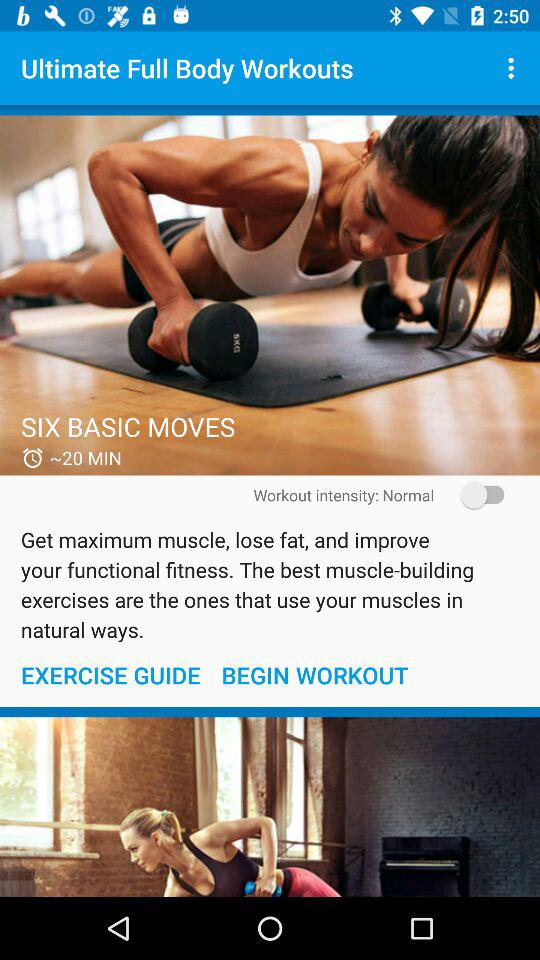What is the workout intensity? The workout intensity is normal. 